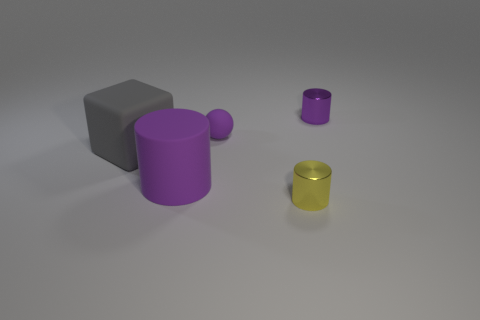Subtract all rubber cylinders. How many cylinders are left? 2 Add 1 big things. How many objects exist? 6 Subtract all yellow cylinders. How many cylinders are left? 2 Subtract all balls. How many objects are left? 4 Subtract all purple balls. Subtract all big purple rubber things. How many objects are left? 3 Add 5 purple metal things. How many purple metal things are left? 6 Add 1 large purple cylinders. How many large purple cylinders exist? 2 Subtract 0 blue cubes. How many objects are left? 5 Subtract 3 cylinders. How many cylinders are left? 0 Subtract all green cubes. Subtract all blue balls. How many cubes are left? 1 